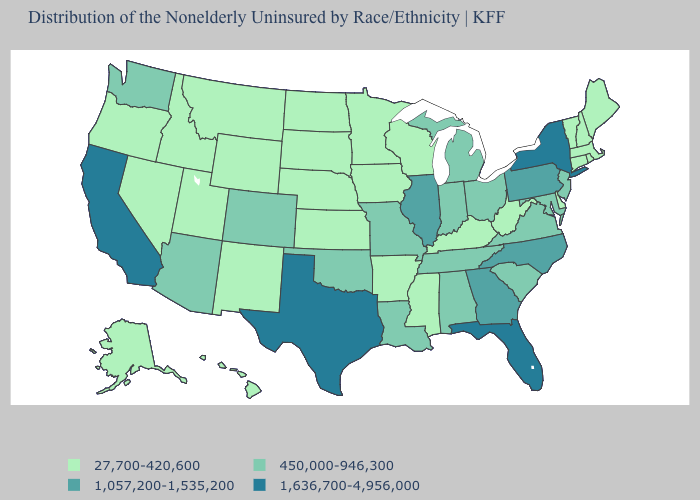Does the first symbol in the legend represent the smallest category?
Answer briefly. Yes. Does Georgia have the highest value in the USA?
Short answer required. No. What is the value of North Dakota?
Write a very short answer. 27,700-420,600. What is the value of Florida?
Give a very brief answer. 1,636,700-4,956,000. What is the value of Colorado?
Quick response, please. 450,000-946,300. Does Ohio have the lowest value in the USA?
Keep it brief. No. Does California have the highest value in the USA?
Write a very short answer. Yes. How many symbols are there in the legend?
Be succinct. 4. Name the states that have a value in the range 27,700-420,600?
Concise answer only. Alaska, Arkansas, Connecticut, Delaware, Hawaii, Idaho, Iowa, Kansas, Kentucky, Maine, Massachusetts, Minnesota, Mississippi, Montana, Nebraska, Nevada, New Hampshire, New Mexico, North Dakota, Oregon, Rhode Island, South Dakota, Utah, Vermont, West Virginia, Wisconsin, Wyoming. Does Connecticut have the same value as Georgia?
Answer briefly. No. Does Wisconsin have the lowest value in the USA?
Quick response, please. Yes. Which states have the lowest value in the USA?
Quick response, please. Alaska, Arkansas, Connecticut, Delaware, Hawaii, Idaho, Iowa, Kansas, Kentucky, Maine, Massachusetts, Minnesota, Mississippi, Montana, Nebraska, Nevada, New Hampshire, New Mexico, North Dakota, Oregon, Rhode Island, South Dakota, Utah, Vermont, West Virginia, Wisconsin, Wyoming. Among the states that border Virginia , which have the highest value?
Be succinct. North Carolina. What is the value of Washington?
Answer briefly. 450,000-946,300. What is the value of New Jersey?
Write a very short answer. 450,000-946,300. 